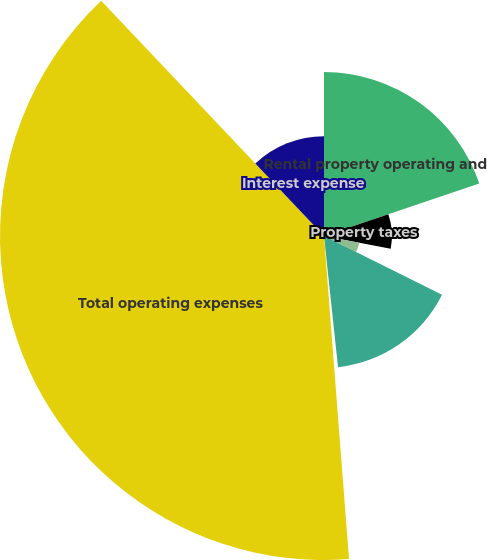<chart> <loc_0><loc_0><loc_500><loc_500><pie_chart><fcel>Rental property operating and<fcel>Property taxes<fcel>Insurance<fcel>Depreciation and amortization<fcel>Other<fcel>Total operating expenses<fcel>Interest expense<nl><fcel>19.81%<fcel>8.21%<fcel>4.34%<fcel>15.94%<fcel>0.47%<fcel>39.16%<fcel>12.07%<nl></chart> 